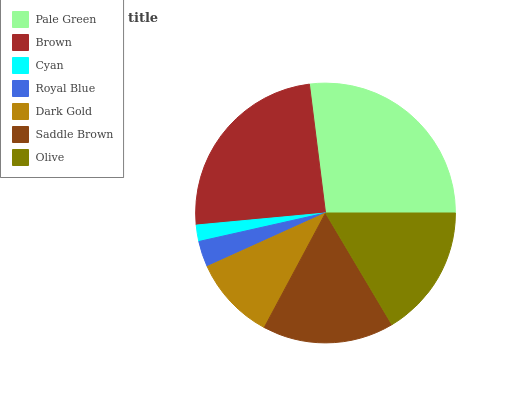Is Cyan the minimum?
Answer yes or no. Yes. Is Pale Green the maximum?
Answer yes or no. Yes. Is Brown the minimum?
Answer yes or no. No. Is Brown the maximum?
Answer yes or no. No. Is Pale Green greater than Brown?
Answer yes or no. Yes. Is Brown less than Pale Green?
Answer yes or no. Yes. Is Brown greater than Pale Green?
Answer yes or no. No. Is Pale Green less than Brown?
Answer yes or no. No. Is Saddle Brown the high median?
Answer yes or no. Yes. Is Saddle Brown the low median?
Answer yes or no. Yes. Is Dark Gold the high median?
Answer yes or no. No. Is Brown the low median?
Answer yes or no. No. 